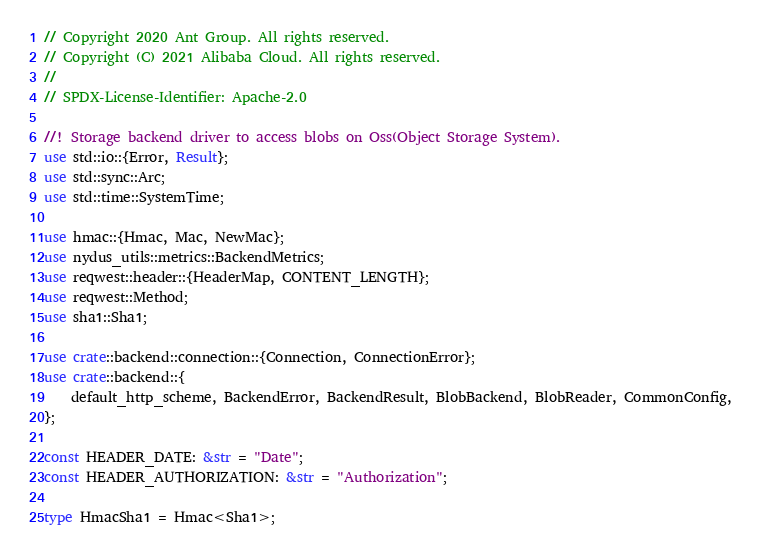Convert code to text. <code><loc_0><loc_0><loc_500><loc_500><_Rust_>// Copyright 2020 Ant Group. All rights reserved.
// Copyright (C) 2021 Alibaba Cloud. All rights reserved.
//
// SPDX-License-Identifier: Apache-2.0

//! Storage backend driver to access blobs on Oss(Object Storage System).
use std::io::{Error, Result};
use std::sync::Arc;
use std::time::SystemTime;

use hmac::{Hmac, Mac, NewMac};
use nydus_utils::metrics::BackendMetrics;
use reqwest::header::{HeaderMap, CONTENT_LENGTH};
use reqwest::Method;
use sha1::Sha1;

use crate::backend::connection::{Connection, ConnectionError};
use crate::backend::{
    default_http_scheme, BackendError, BackendResult, BlobBackend, BlobReader, CommonConfig,
};

const HEADER_DATE: &str = "Date";
const HEADER_AUTHORIZATION: &str = "Authorization";

type HmacSha1 = Hmac<Sha1>;
</code> 